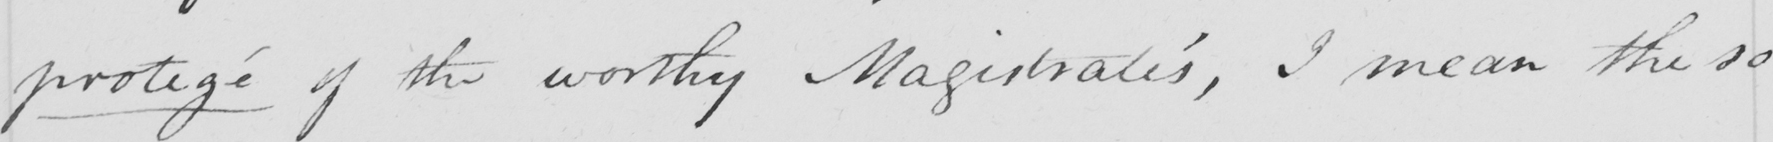Please provide the text content of this handwritten line. protegé of the worthy Magistrates , I mean the so 